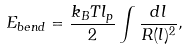<formula> <loc_0><loc_0><loc_500><loc_500>E _ { b e n d } = \frac { k _ { B } T l _ { p } } { 2 } \int \frac { d l } { R ( l ) ^ { 2 } } ,</formula> 